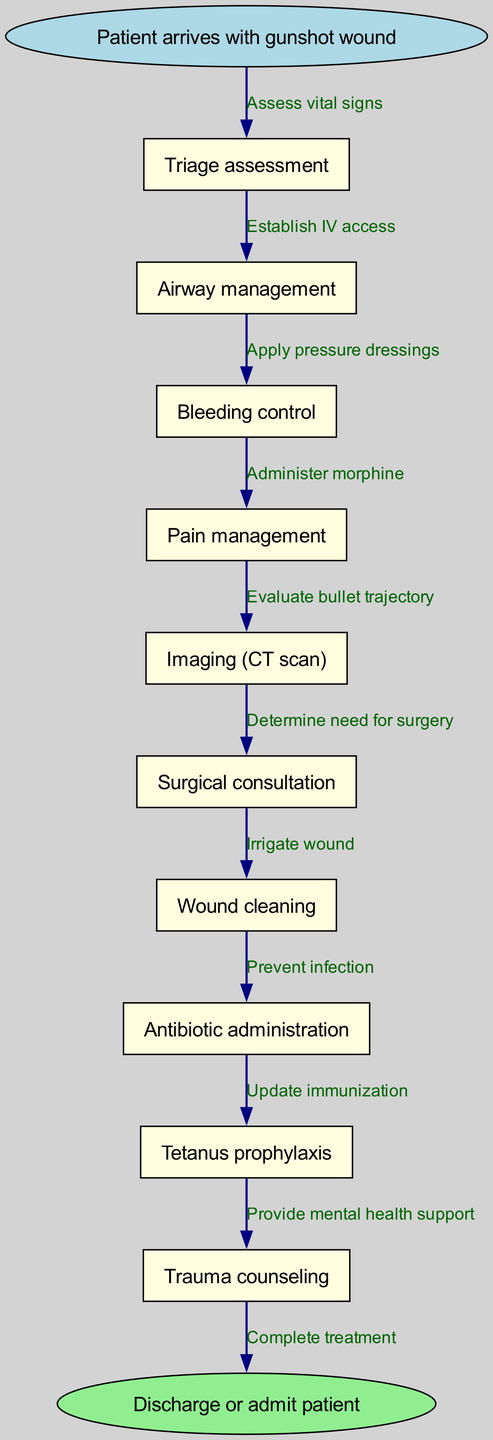What is the starting point of the clinical pathway? The diagram starts with the patient arriving with a gunshot wound, which is indicated as the initial node. This serves as the entry point into the clinical pathway.
Answer: Patient arrives with gunshot wound How many nodes are present in the diagram? The diagram includes a total of ten nodes, which consist of the start node, the end node, and the eight intermediate steps in the treatment process.
Answer: Ten What is the final stage of the clinical pathway? The final stage is represented by the end node, which indicates the completion of the treatment process with either discharge or admission of the patient.
Answer: Discharge or admit patient What treatment follows "Bleeding control"? After "Bleeding control," the next treatment step in the pathway is "Pain management," as shown by the directed edges connecting these nodes in the diagram.
Answer: Pain management Which node involves a surgical decision? The node that involves a surgical decision is "Surgical consultation." This step is critical as it determines whether surgery is necessary based on the patient's condition after prior assessments.
Answer: Surgical consultation What is the connection between "Antibiotic administration" and "Prevent infection"? "Antibiotic administration" directly relates to "Prevent infection" because administering antibiotics is a method used to reduce the risk of infection at the wound site.
Answer: Antibiotic administration How many edges are there in the diagram? The diagram shows nine edges, which represent the connections between the nodes indicating the flow of treatment actions that follow each assessment and intervention.
Answer: Nine What is the first action taken after the triage assessment? The first action taken following the "Triage assessment" is "Airway management," which is crucial in ensuring that the patient can breathe adequately in the initial stages of treatment.
Answer: Airway management What might be a reason for "Trauma counseling" in the pathway? "Trauma counseling" may be included in the pathway to provide mental health support to patients dealing with the psychological effects of experiencing a gunshot wound, acknowledging the importance of mental health in trauma care.
Answer: Mental health support 